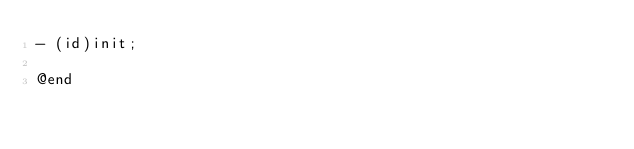Convert code to text. <code><loc_0><loc_0><loc_500><loc_500><_C_>- (id)init;

@end
</code> 